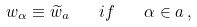<formula> <loc_0><loc_0><loc_500><loc_500>w _ { \alpha } \equiv \widetilde { w } _ { a } \quad i f \quad \alpha \in a \, ,</formula> 